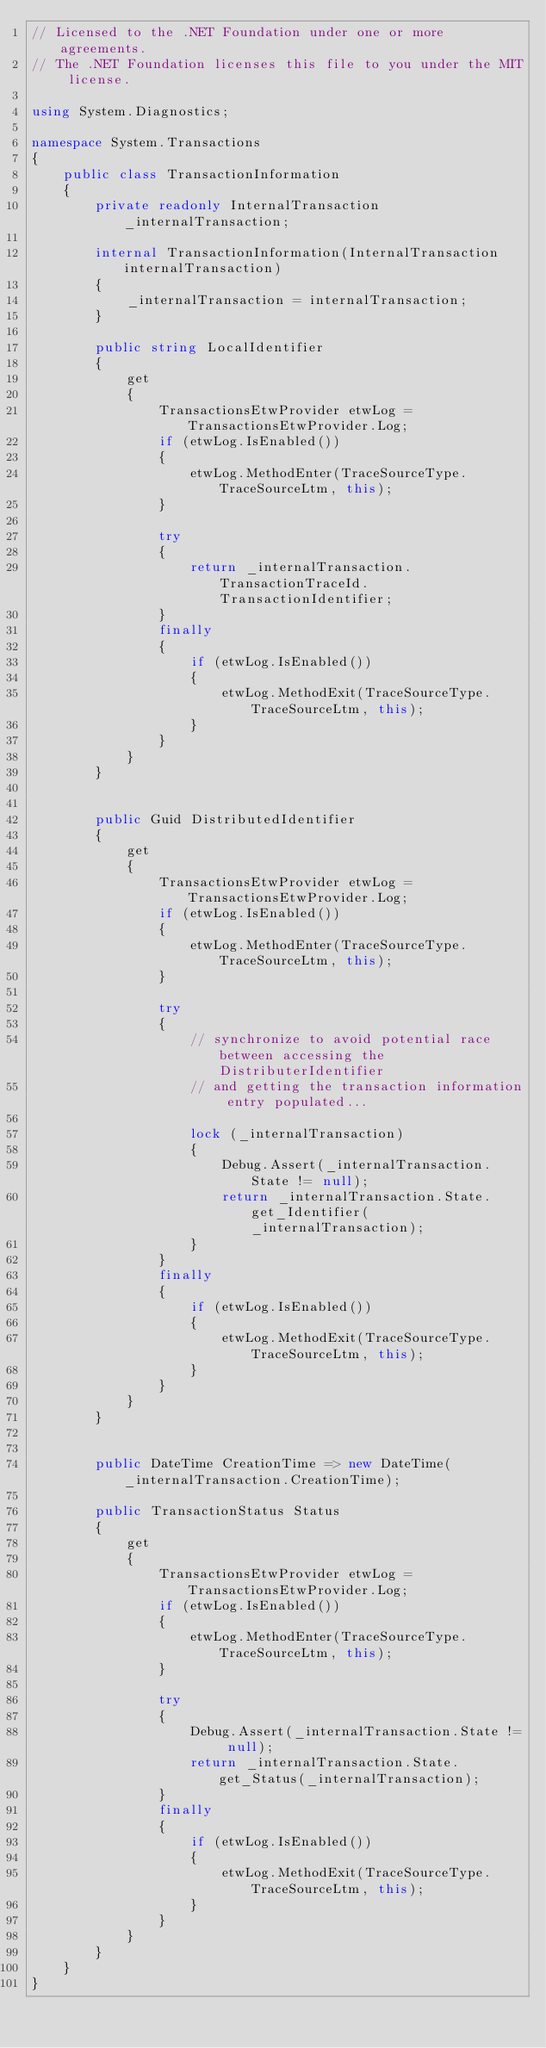<code> <loc_0><loc_0><loc_500><loc_500><_C#_>// Licensed to the .NET Foundation under one or more agreements.
// The .NET Foundation licenses this file to you under the MIT license.

using System.Diagnostics;

namespace System.Transactions
{
    public class TransactionInformation
    {
        private readonly InternalTransaction _internalTransaction;

        internal TransactionInformation(InternalTransaction internalTransaction)
        {
            _internalTransaction = internalTransaction;
        }

        public string LocalIdentifier
        {
            get
            {
                TransactionsEtwProvider etwLog = TransactionsEtwProvider.Log;
                if (etwLog.IsEnabled())
                {
                    etwLog.MethodEnter(TraceSourceType.TraceSourceLtm, this);
                }

                try
                {
                    return _internalTransaction.TransactionTraceId.TransactionIdentifier;
                }
                finally
                {
                    if (etwLog.IsEnabled())
                    {
                        etwLog.MethodExit(TraceSourceType.TraceSourceLtm, this);
                    }
                }
            }
        }


        public Guid DistributedIdentifier
        {
            get
            {
                TransactionsEtwProvider etwLog = TransactionsEtwProvider.Log;
                if (etwLog.IsEnabled())
                {
                    etwLog.MethodEnter(TraceSourceType.TraceSourceLtm, this);
                }

                try
                {
                    // synchronize to avoid potential race between accessing the DistributerIdentifier
                    // and getting the transaction information entry populated...

                    lock (_internalTransaction)
                    {
                        Debug.Assert(_internalTransaction.State != null);
                        return _internalTransaction.State.get_Identifier(_internalTransaction);
                    }
                }
                finally
                {
                    if (etwLog.IsEnabled())
                    {
                        etwLog.MethodExit(TraceSourceType.TraceSourceLtm, this);
                    }
                }
            }
        }


        public DateTime CreationTime => new DateTime(_internalTransaction.CreationTime);

        public TransactionStatus Status
        {
            get
            {
                TransactionsEtwProvider etwLog = TransactionsEtwProvider.Log;
                if (etwLog.IsEnabled())
                {
                    etwLog.MethodEnter(TraceSourceType.TraceSourceLtm, this);
                }

                try
                {
                    Debug.Assert(_internalTransaction.State != null);
                    return _internalTransaction.State.get_Status(_internalTransaction);
                }
                finally
                {
                    if (etwLog.IsEnabled())
                    {
                        etwLog.MethodExit(TraceSourceType.TraceSourceLtm, this);
                    }
                }
            }
        }
    }
}
</code> 